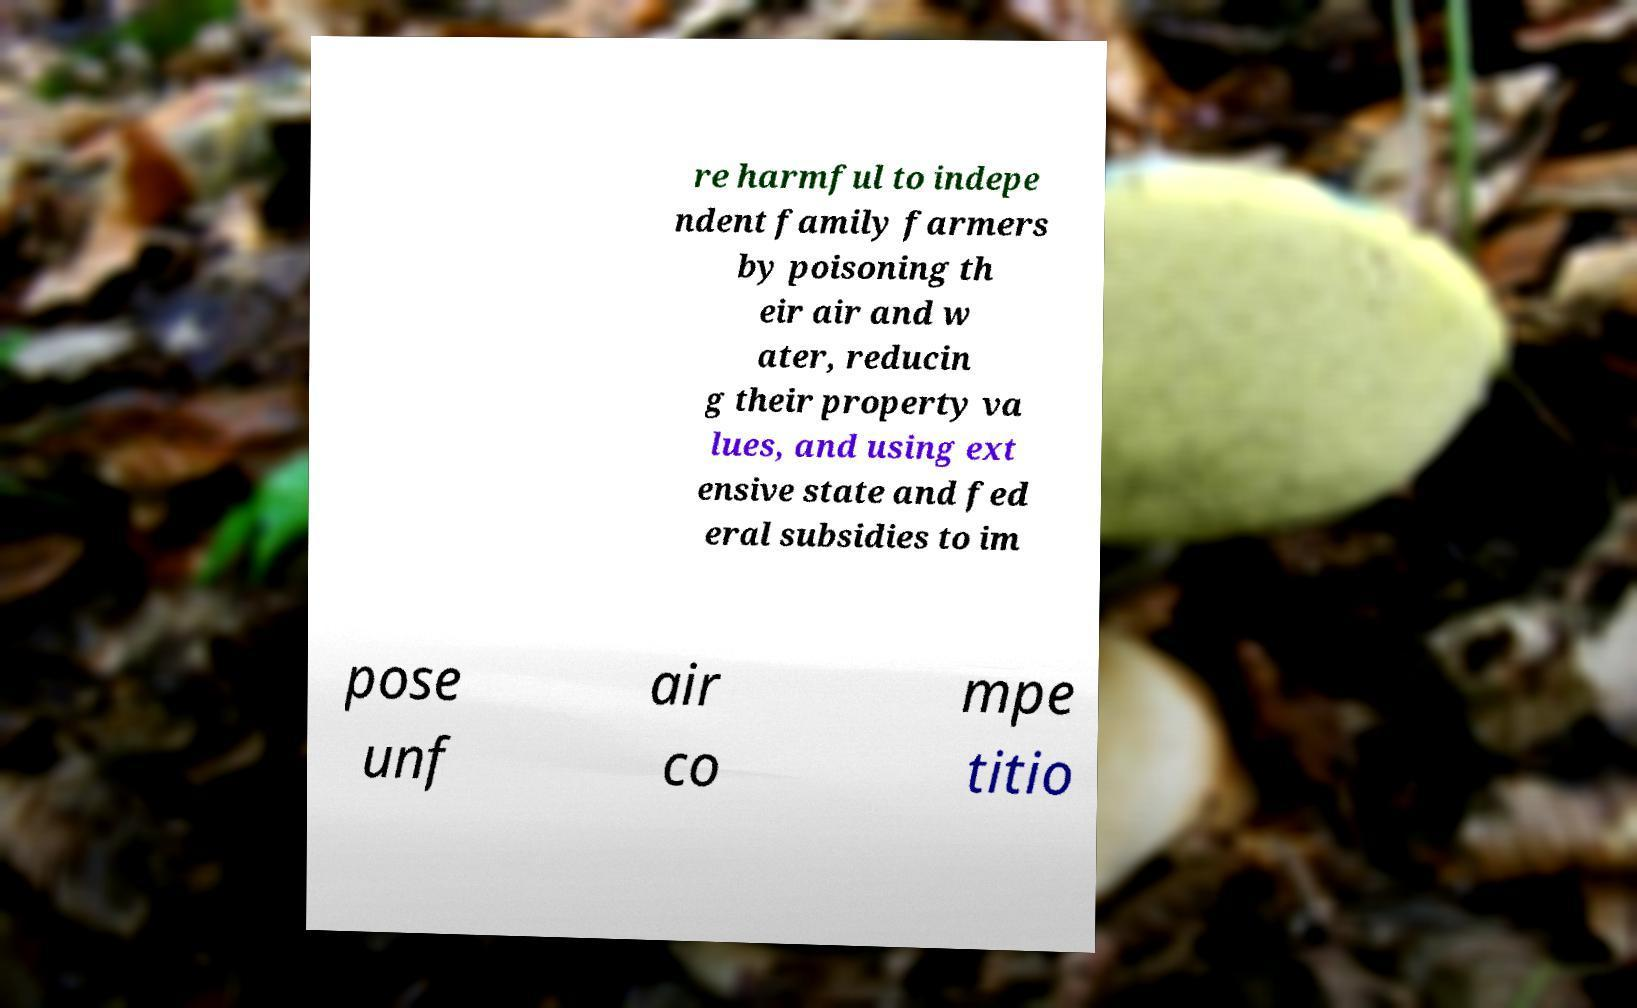Can you accurately transcribe the text from the provided image for me? re harmful to indepe ndent family farmers by poisoning th eir air and w ater, reducin g their property va lues, and using ext ensive state and fed eral subsidies to im pose unf air co mpe titio 